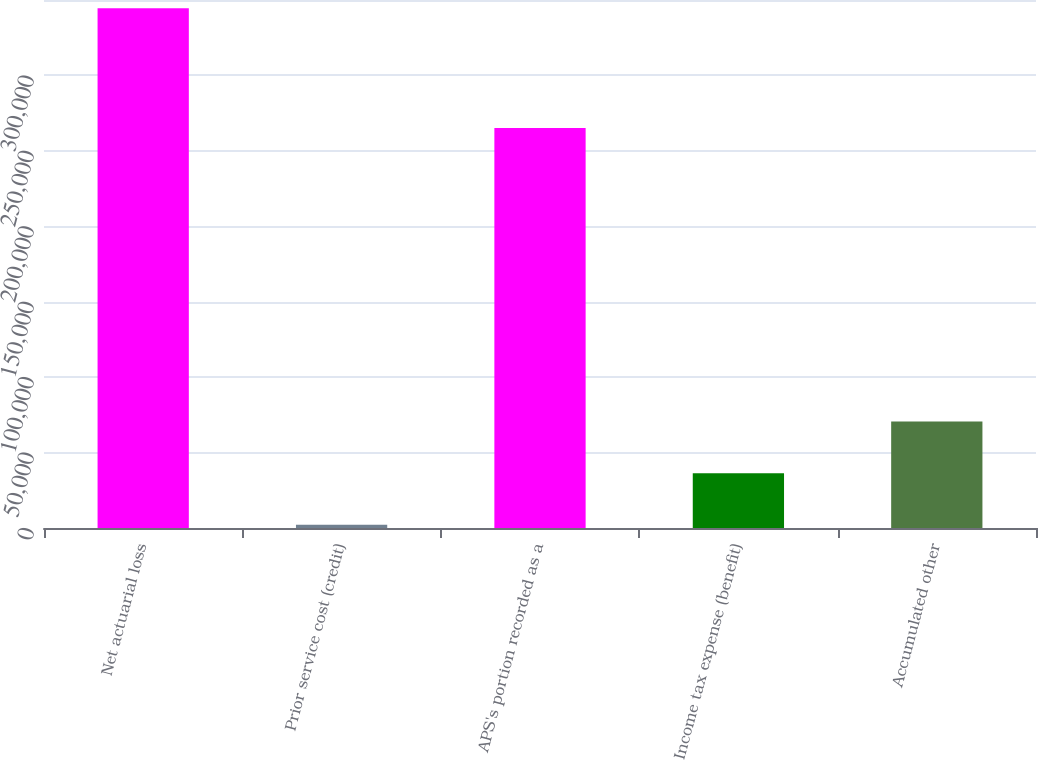<chart> <loc_0><loc_0><loc_500><loc_500><bar_chart><fcel>Net actuarial loss<fcel>Prior service cost (credit)<fcel>APS's portion recorded as a<fcel>Income tax expense (benefit)<fcel>Accumulated other<nl><fcel>344540<fcel>2072<fcel>265107<fcel>36318.8<fcel>70565.6<nl></chart> 